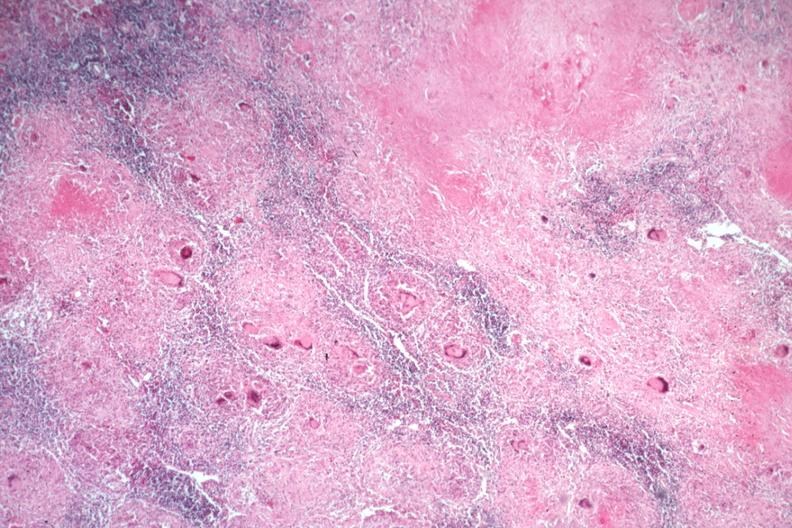how does this image show typical caseating lesions?
Answer the question using a single word or phrase. With many langerhans giant cells 